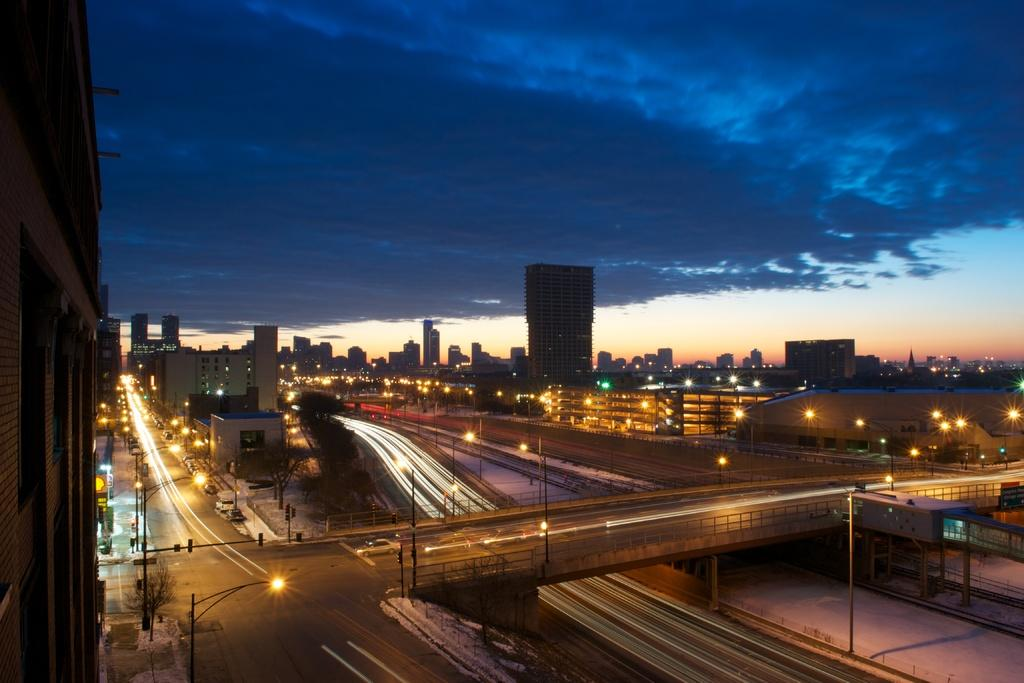What types of objects can be seen in the image? There are vehicles, lights, buildings, boards with text, roads, poles, trees, and lights in the image. Can you describe the weather condition in the image? The sky is cloudy in the image. What might be used for transportation in the image? Vehicles can be used for transportation in the image. What type of surface can be seen in the image? Roads are visible in the image. What type of prose is being recited by the trees in the image? There are no trees reciting prose in the image; the trees are stationary and not engaged in any literary activity. 